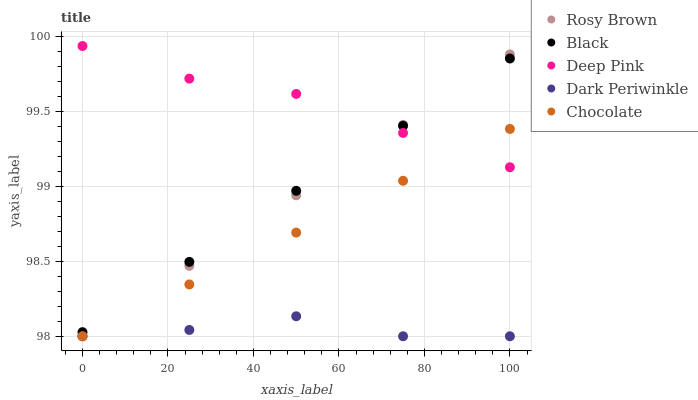Does Dark Periwinkle have the minimum area under the curve?
Answer yes or no. Yes. Does Deep Pink have the maximum area under the curve?
Answer yes or no. Yes. Does Black have the minimum area under the curve?
Answer yes or no. No. Does Black have the maximum area under the curve?
Answer yes or no. No. Is Chocolate the smoothest?
Answer yes or no. Yes. Is Dark Periwinkle the roughest?
Answer yes or no. Yes. Is Black the smoothest?
Answer yes or no. No. Is Black the roughest?
Answer yes or no. No. Does Rosy Brown have the lowest value?
Answer yes or no. Yes. Does Black have the lowest value?
Answer yes or no. No. Does Deep Pink have the highest value?
Answer yes or no. Yes. Does Black have the highest value?
Answer yes or no. No. Is Chocolate less than Black?
Answer yes or no. Yes. Is Black greater than Dark Periwinkle?
Answer yes or no. Yes. Does Dark Periwinkle intersect Chocolate?
Answer yes or no. Yes. Is Dark Periwinkle less than Chocolate?
Answer yes or no. No. Is Dark Periwinkle greater than Chocolate?
Answer yes or no. No. Does Chocolate intersect Black?
Answer yes or no. No. 